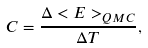Convert formula to latex. <formula><loc_0><loc_0><loc_500><loc_500>C = \frac { \Delta < E > _ { Q M C } } { \Delta T } ,</formula> 